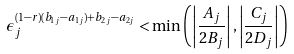Convert formula to latex. <formula><loc_0><loc_0><loc_500><loc_500>\epsilon _ { j } ^ { ( 1 - r ) ( b _ { 1 j } - a _ { 1 j } ) + b _ { 2 j } - a _ { 2 j } } < \min \left ( \left | \frac { A _ { j } } { 2 B _ { j } } \right | , \left | \frac { C _ { j } } { 2 D _ { j } } \right | \right )</formula> 